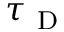<formula> <loc_0><loc_0><loc_500><loc_500>\tau _ { D }</formula> 